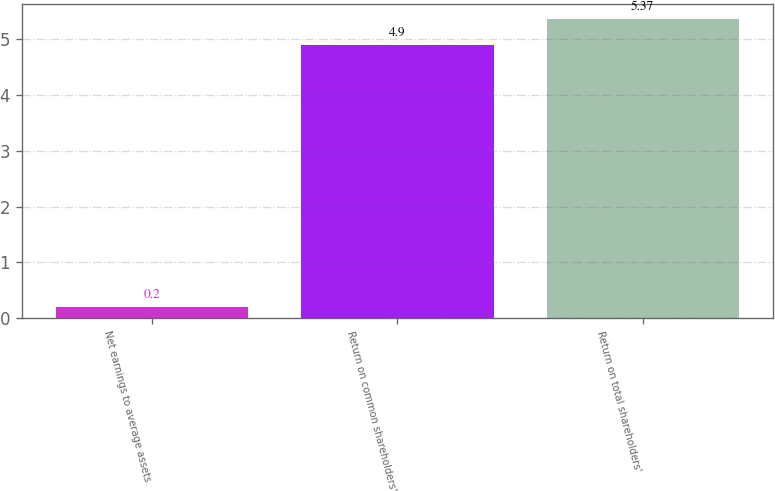Convert chart. <chart><loc_0><loc_0><loc_500><loc_500><bar_chart><fcel>Net earnings to average assets<fcel>Return on common shareholders'<fcel>Return on total shareholders'<nl><fcel>0.2<fcel>4.9<fcel>5.37<nl></chart> 